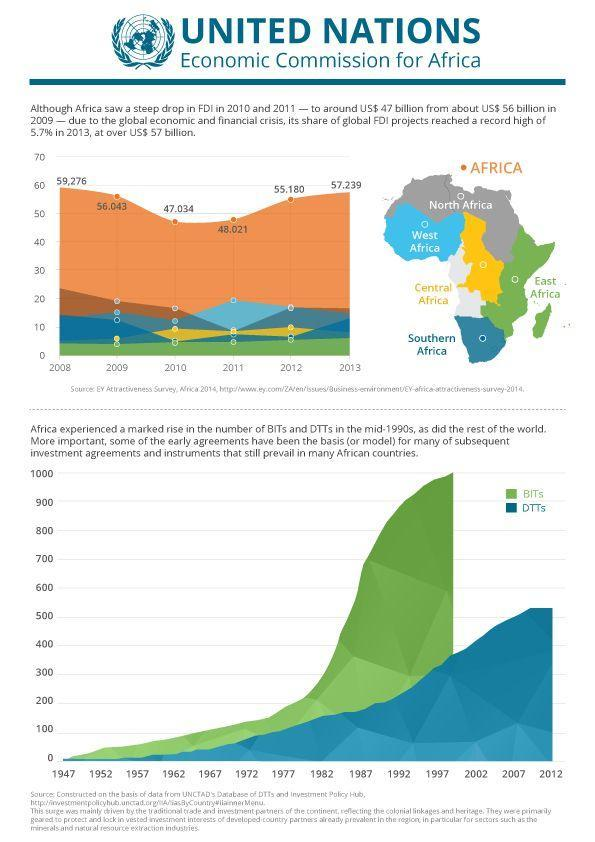Which African Region shows a consistent growth in FDI from the year 2008-2013?
Answer the question with a short phrase. East Africa What was the decrease in FDI in Africa in the year 2010-11 from the year 2009 ? $ 9 billion Which year shows the highest contribution to FDI by the West African region ? 2011 How many regions has Africa been divided into ? 6 